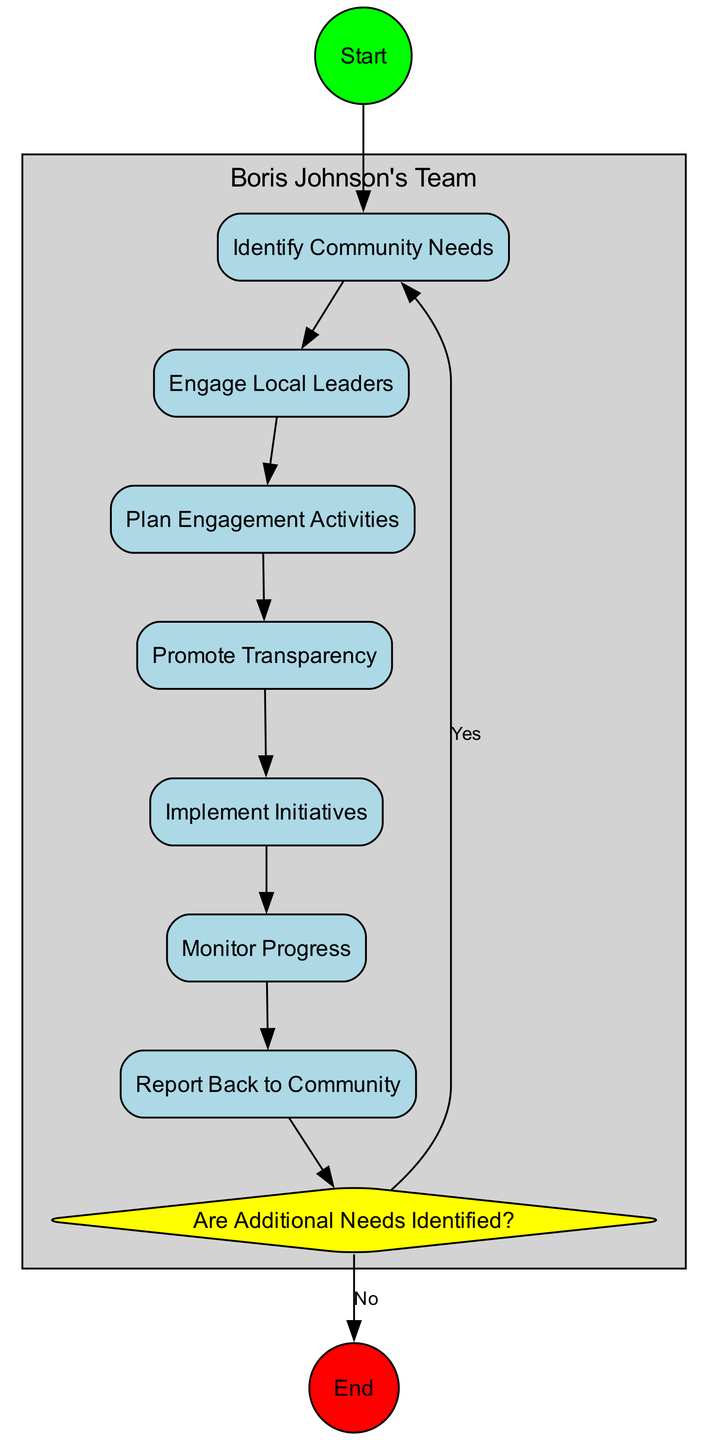What is the starting action in the diagram? The starting action is "Identify Community Needs", as it is the first node connected to the start node.
Answer: Identify Community Needs How many actions are there in total? There are seven actions in the diagram, as counted from the list provided in the data.
Answer: Seven What follows after "Promote Transparency"? The action that follows "Promote Transparency" is "Implement Initiatives", as indicated by the connection leading from the former to the latter.
Answer: Implement Initiatives What decision is made after "Monitor Progress"? The decision made after "Monitor Progress" is "Are Additional Needs Identified?", as it is the next node connected to this action.
Answer: Are Additional Needs Identified? If additional needs are identified, which action is revisited? The action that is revisited if additional needs are identified is "Identify Community Needs", as indicated by the flow from the decision point when "Yes" is selected.
Answer: Identify Community Needs How many swimlanes are in the diagram? There is one swimlane in the diagram, as mentioned in the provided data which details the involvement of Boris Johnson's Team.
Answer: One What is the final action taken in the diagram? The final action taken in the diagram is "Report Back to Community", as it is the last node in the workflow before the end node.
Answer: Report Back to Community What is the shape of decision nodes in this diagram? The shape of decision nodes in this diagram is a diamond, which is a standard representation for decision points in activity diagrams.
Answer: Diamond 